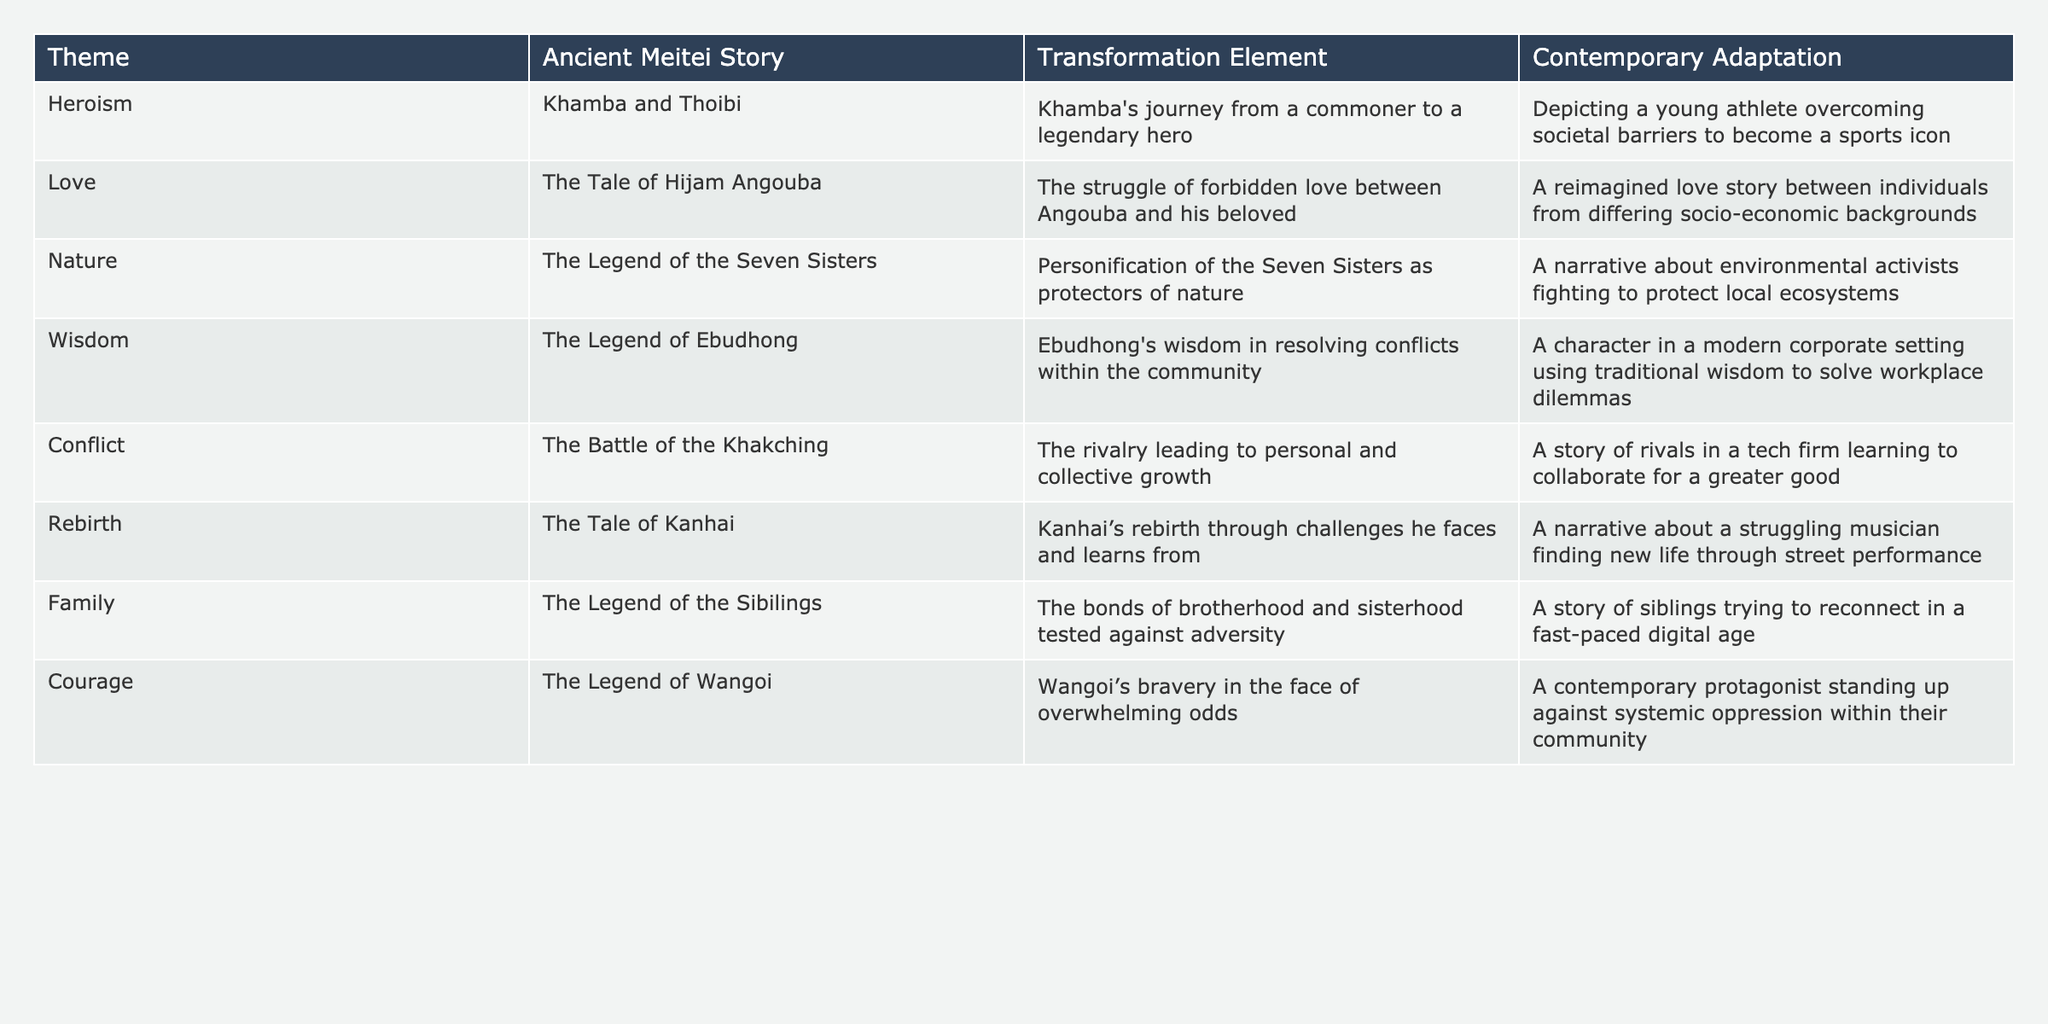What is the transformation element in the story of Khamba and Thoibi? The transformation element is Khamba's journey from a commoner to a legendary hero.
Answer: Khamba's journey from a commoner to a legendary hero In how many stories is the theme of love present? The theme of love is present in one story, which is The Tale of Hijam Angouba.
Answer: One story Which contemporary adaptation reflects themes of nature? The contemporary adaptation about environmental activists fighting to protect local ecosystems reflects themes of nature.
Answer: Environmental activists fighting to protect local ecosystems What is the transformation element in The Legend of Wangoi? The transformation element is Wangoi's bravery in the face of overwhelming odds.
Answer: Wangoi's bravery in the face of overwhelming odds Are all themes represented in the table with corresponding stories? Yes, all themes listed in the table are represented with corresponding stories.
Answer: Yes Which story features a struggle with forbidden love? The story that features a struggle with forbidden love is The Tale of Hijam Angouba.
Answer: The Tale of Hijam Angouba Is the theme of rebirth associated with personal growth? Yes, the theme of rebirth in The Tale of Kanhai is associated with personal growth through challenges.
Answer: Yes How many of the adaptations involve a central character overcoming societal challenges? Two adaptations, Khamba and Thoibi and The Legend of Wangoi, involve a central character overcoming societal challenges.
Answer: Two adaptations Which theme includes a character using traditional wisdom in a modern setting? The theme of wisdom includes a character using traditional wisdom in a modern corporate setting.
Answer: Wisdom What is the relationship between the theme of courage and the contemporary adaptation provided? The theme of courage showcases a contemporary protagonist standing up against systemic oppression, indicating personal bravery in social contexts.
Answer: Personal bravery in social contexts 